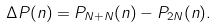<formula> <loc_0><loc_0><loc_500><loc_500>\Delta P ( n ) = P _ { N + N } ( n ) - P _ { 2 N } ( n ) .</formula> 